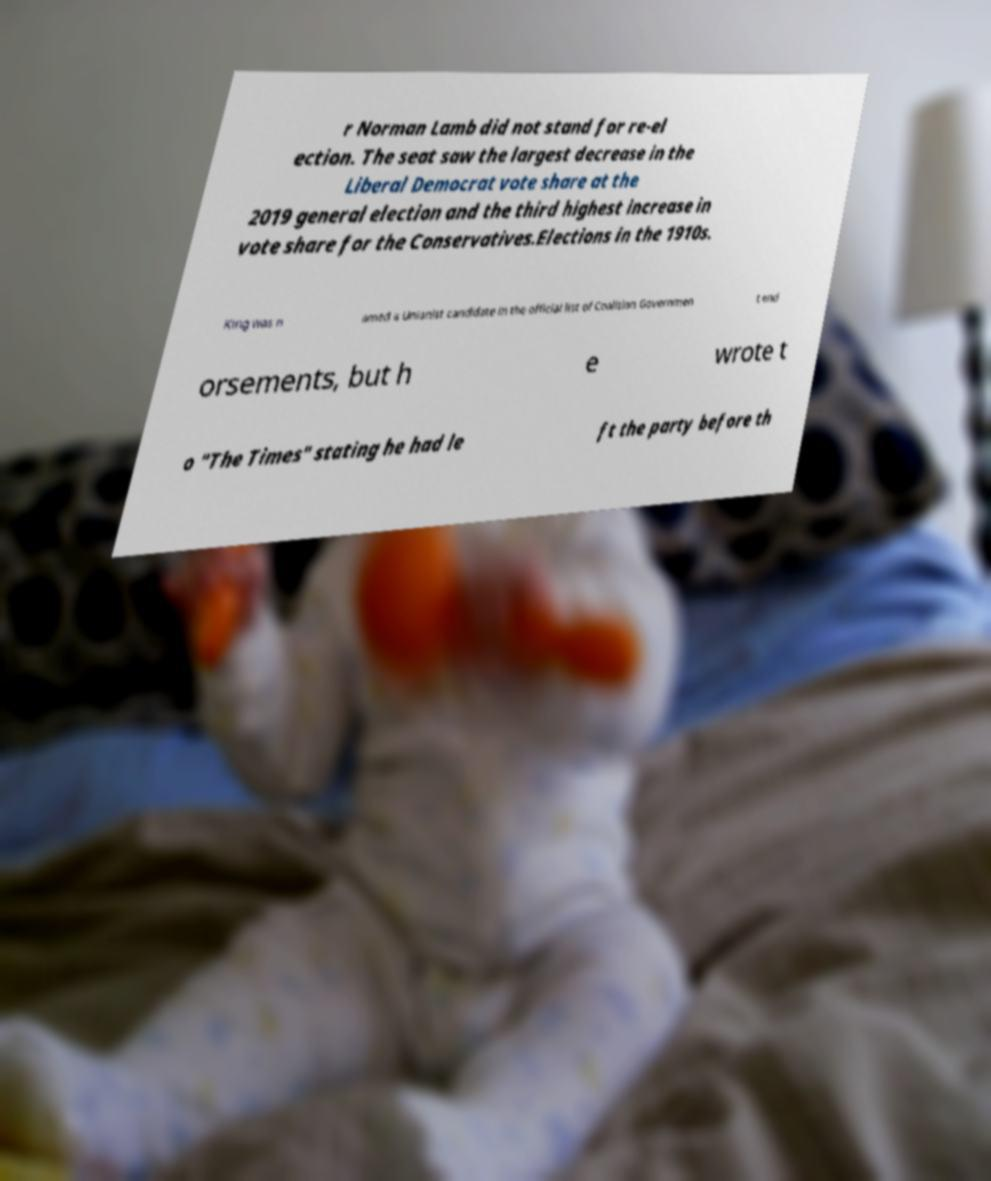I need the written content from this picture converted into text. Can you do that? r Norman Lamb did not stand for re-el ection. The seat saw the largest decrease in the Liberal Democrat vote share at the 2019 general election and the third highest increase in vote share for the Conservatives.Elections in the 1910s. King was n amed a Unionist candidate in the official list of Coalition Governmen t end orsements, but h e wrote t o "The Times" stating he had le ft the party before th 